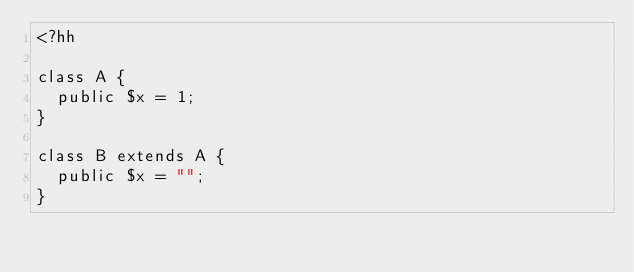<code> <loc_0><loc_0><loc_500><loc_500><_PHP_><?hh

class A {
  public $x = 1;
}

class B extends A {
  public $x = "";
}
</code> 